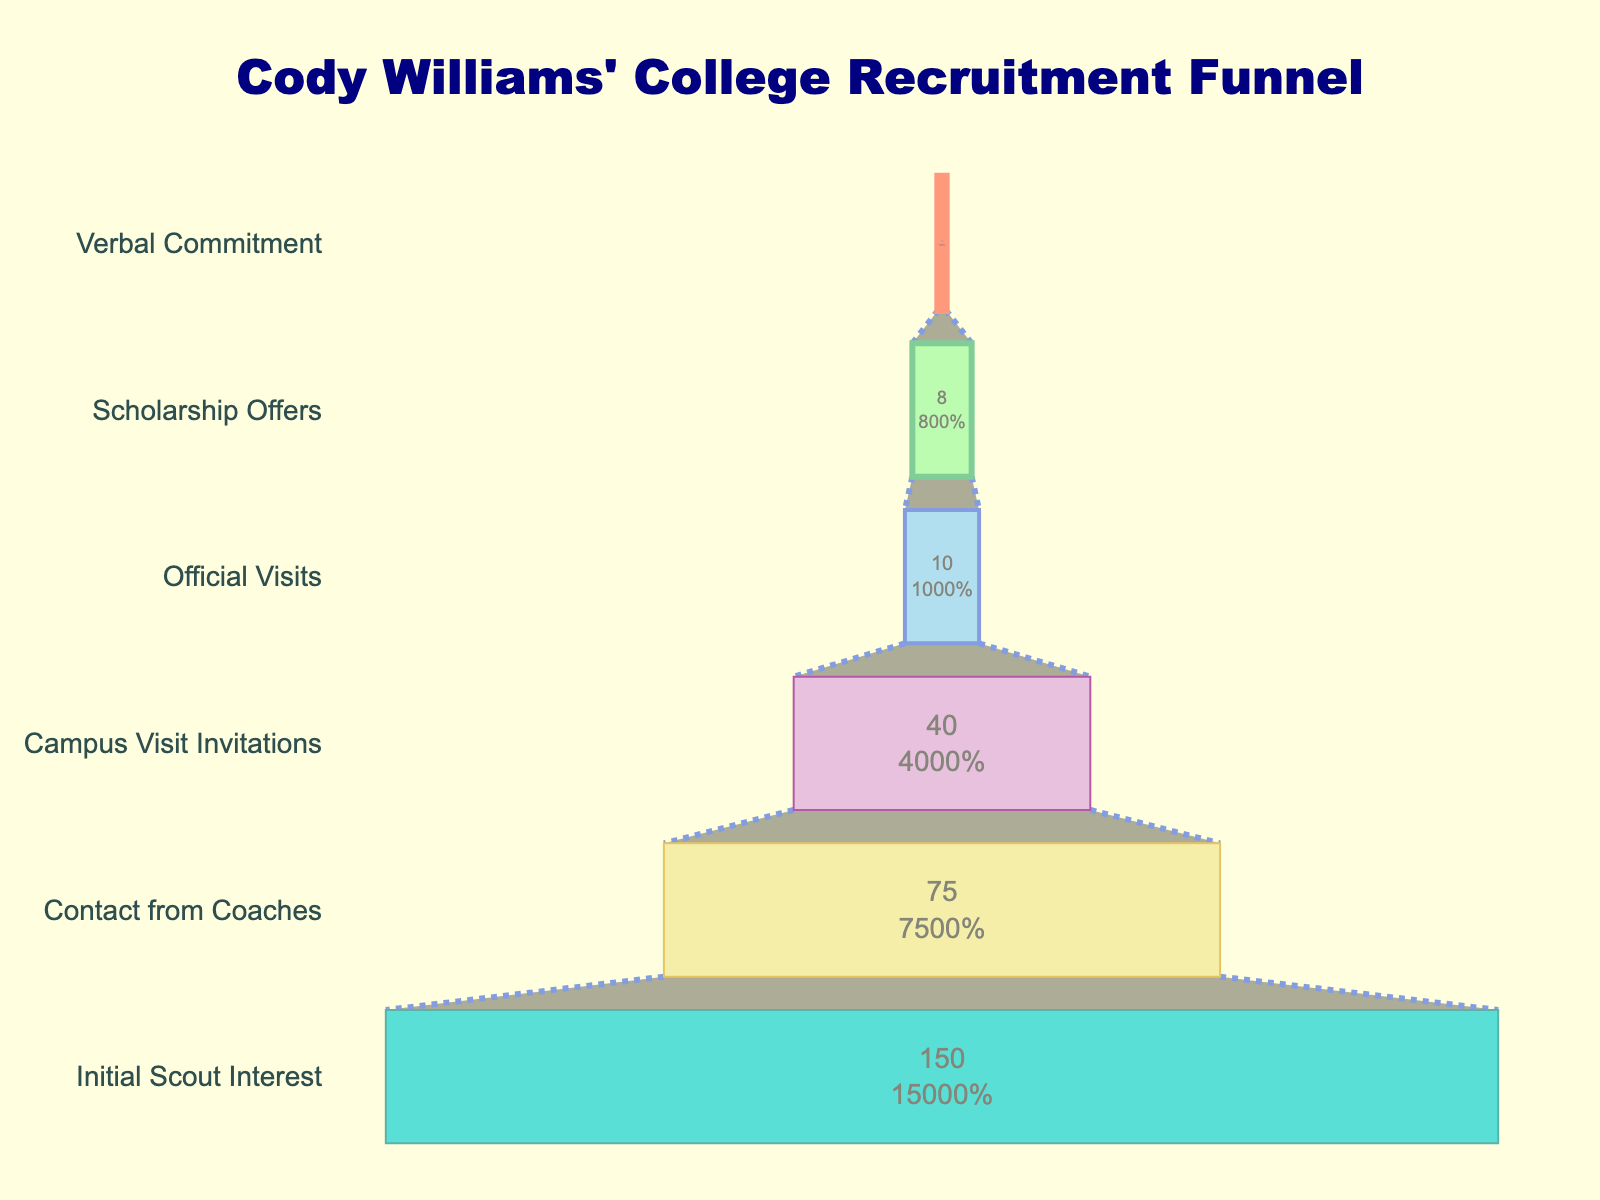Which stage has the highest number of schools showing interest? To answer this question, look at the funnel chart and identify the stage with the largest value. The top stage, "Initial Scout Interest," has the highest number of schools, which is 150.
Answer: Initial Scout Interest How many schools invited Cody for campus visits? Look at the bar labeled "Campus Visit Invitations" to see the number of schools, which is 40.
Answer: 40 What percentage of initial scouts ended up making scholarship offers? The funnel chart provides the percentage of schools at each stage relative to the initial interest. For "Scholarship Offers," this is shown as around 5.3% of the initial 150 schools.
Answer: 5.3% Compare the number of schools that made official visits with those that made scholarship offers. Which is greater and by how much? Identify the values for "Official Visits" and "Scholarship Offers." Official Visits are 10, and Scholarship Offers are 8. The difference is 10 - 8 = 2.
Answer: Official Visits is greater by 2 Which stage shows the biggest drop in the number of schools from the previous stage? The stages need to be analyzed to find the largest numerical difference. From "Initial Scout Interest" to "Contact from Coaches," the drop is 150 - 75 = 75, which is the largest drop.
Answer: Initial Scout Interest to Contact from Coaches At which stage did more than half of the initially interested schools drop off? Compare the remaining schools at each stage with half of the initial interest (150/2 = 75). The drop-off to below half happens at the "Campus Visit Invitations" stage, where 40 schools remain.
Answer: Campus Visit Invitations What is Cody Williams' verbal commitment in terms of percentage of initial scout interest? The final stage, "Verbal Commitment," is 1 school. The percentage is (1/150) * 100 = 0.67%.
Answer: 0.67% How many stages are represented in the recruitment funnel? Count the number of different stages listed on the Y-axis of the funnel chart. There are six stages represented.
Answer: Six Which stage is colored light green? By looking at the colors used in the chart, the stage "Contact from Coaches" is represented in light green.
Answer: Contact from Coaches 